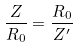Convert formula to latex. <formula><loc_0><loc_0><loc_500><loc_500>\frac { Z } { R _ { 0 } } = \frac { R _ { 0 } } { Z ^ { \prime } }</formula> 